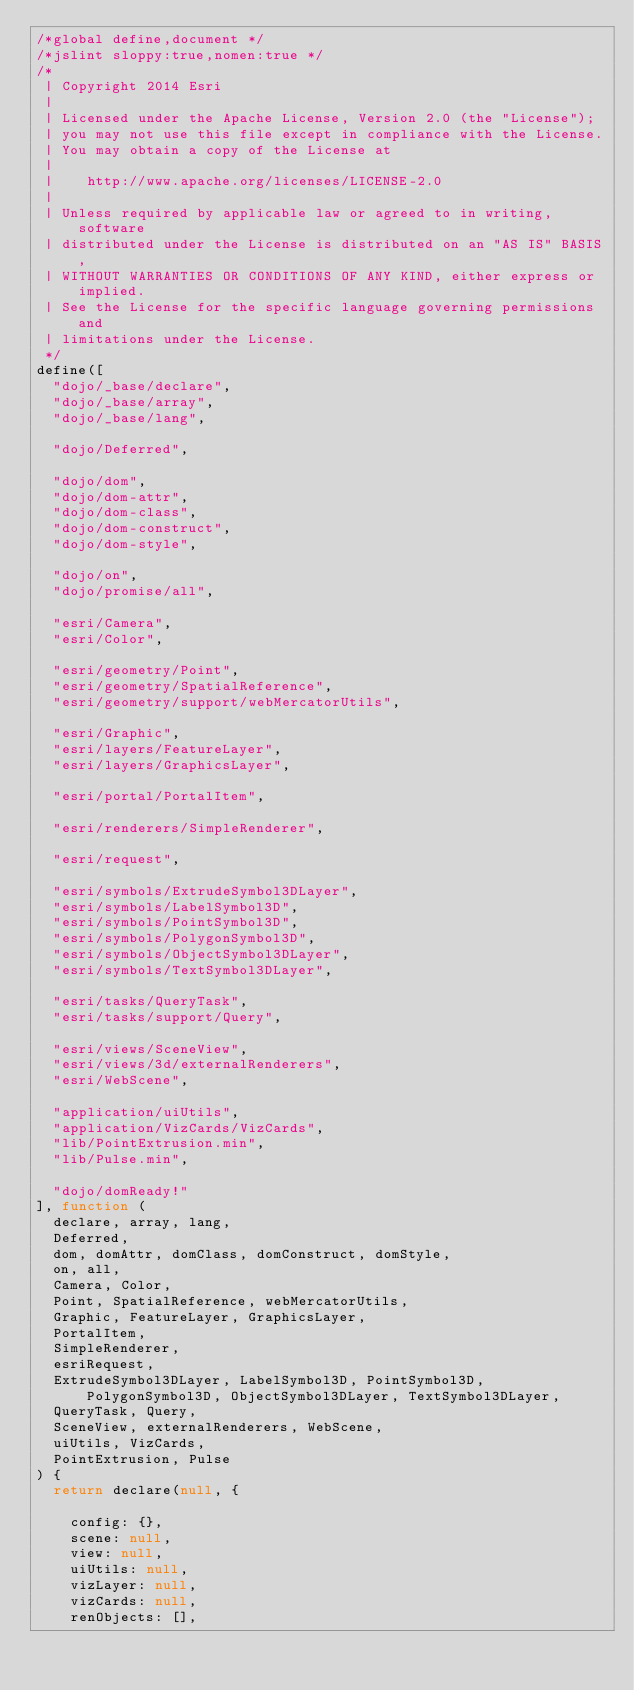Convert code to text. <code><loc_0><loc_0><loc_500><loc_500><_JavaScript_>/*global define,document */
/*jslint sloppy:true,nomen:true */
/*
 | Copyright 2014 Esri
 |
 | Licensed under the Apache License, Version 2.0 (the "License");
 | you may not use this file except in compliance with the License.
 | You may obtain a copy of the License at
 |
 |    http://www.apache.org/licenses/LICENSE-2.0
 |
 | Unless required by applicable law or agreed to in writing, software
 | distributed under the License is distributed on an "AS IS" BASIS,
 | WITHOUT WARRANTIES OR CONDITIONS OF ANY KIND, either express or implied.
 | See the License for the specific language governing permissions and
 | limitations under the License.
 */
define([
  "dojo/_base/declare",
  "dojo/_base/array",
  "dojo/_base/lang",

  "dojo/Deferred",

  "dojo/dom",
  "dojo/dom-attr",
  "dojo/dom-class",
  "dojo/dom-construct",
  "dojo/dom-style",

  "dojo/on",
  "dojo/promise/all",

  "esri/Camera",
  "esri/Color",

  "esri/geometry/Point",
  "esri/geometry/SpatialReference",
  "esri/geometry/support/webMercatorUtils",

  "esri/Graphic",
  "esri/layers/FeatureLayer",
  "esri/layers/GraphicsLayer",

  "esri/portal/PortalItem",

  "esri/renderers/SimpleRenderer",

  "esri/request",

  "esri/symbols/ExtrudeSymbol3DLayer",
  "esri/symbols/LabelSymbol3D",
  "esri/symbols/PointSymbol3D",
  "esri/symbols/PolygonSymbol3D",
  "esri/symbols/ObjectSymbol3DLayer",
  "esri/symbols/TextSymbol3DLayer",

  "esri/tasks/QueryTask",
  "esri/tasks/support/Query",

  "esri/views/SceneView",
  "esri/views/3d/externalRenderers",
  "esri/WebScene",

  "application/uiUtils",
  "application/VizCards/VizCards",
  "lib/PointExtrusion.min",
  "lib/Pulse.min",

  "dojo/domReady!"
], function (
  declare, array, lang,
  Deferred,
  dom, domAttr, domClass, domConstruct, domStyle,
  on, all,
  Camera, Color,
  Point, SpatialReference, webMercatorUtils,
  Graphic, FeatureLayer, GraphicsLayer,
  PortalItem,
  SimpleRenderer,
  esriRequest,
  ExtrudeSymbol3DLayer, LabelSymbol3D, PointSymbol3D, PolygonSymbol3D, ObjectSymbol3DLayer, TextSymbol3DLayer,
  QueryTask, Query,
  SceneView, externalRenderers, WebScene,
  uiUtils, VizCards,
  PointExtrusion, Pulse
) {
  return declare(null, {

    config: {},
    scene: null,
    view: null,
    uiUtils: null,
    vizLayer: null,
    vizCards: null,
    renObjects: [],
</code> 